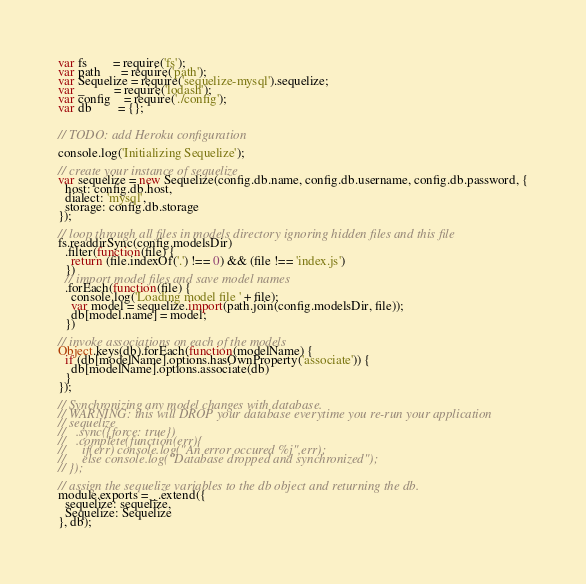<code> <loc_0><loc_0><loc_500><loc_500><_JavaScript_>var fs        = require('fs');
var path      = require('path');
var Sequelize = require('sequelize-mysql').sequelize;
var _         = require('lodash');
var config    = require('./config');
var db        = {};


// TODO: add Heroku configuration

console.log('Initializing Sequelize');

// create your instance of sequelize
var sequelize = new Sequelize(config.db.name, config.db.username, config.db.password, {
  host: config.db.host,
  dialect: 'mysql',
  storage: config.db.storage
});

// loop through all files in models directory ignoring hidden files and this file
fs.readdirSync(config.modelsDir)
  .filter(function(file) {
    return (file.indexOf('.') !== 0) && (file !== 'index.js')
  })
  // import model files and save model names
  .forEach(function(file) {
    console.log('Loading model file ' + file);
    var model = sequelize.import(path.join(config.modelsDir, file));
    db[model.name] = model;
  })

// invoke associations on each of the models
Object.keys(db).forEach(function(modelName) {
  if (db[modelName].options.hasOwnProperty('associate')) {
    db[modelName].options.associate(db)
  }
});

// Synchronizing any model changes with database. 
// WARNING: this will DROP your database everytime you re-run your application
// sequelize
//   .sync({force: true})
//   .complete(function(err){
//     if(err) console.log("An error occured %j",err);
//     else console.log("Database dropped and synchronized");
// });
 
// assign the sequelize variables to the db object and returning the db. 
module.exports = _.extend({
  sequelize: sequelize,
  Sequelize: Sequelize
}, db);</code> 